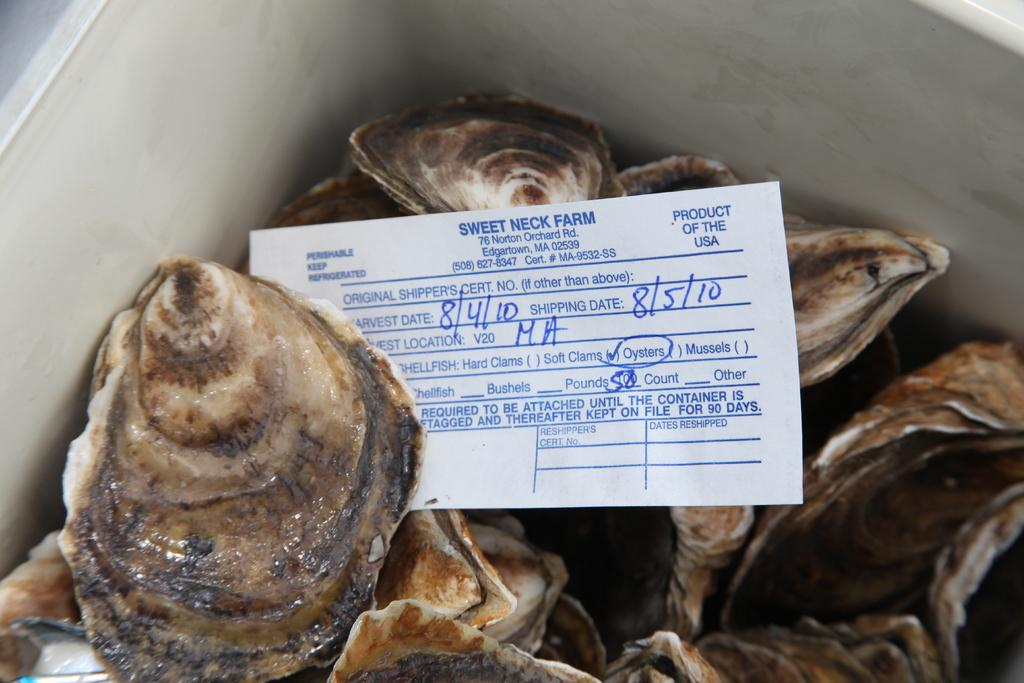What objects are present in the image? There are seashells in the image, which are kept in a box. How are the seashells stored? The seashells are kept in a box. What else can be seen in the image besides the seashells? There is a paper slip in the image. Where is the paper slip located in relation to the box of seashells? The paper slip is placed on the box of seashells. What type of notebook is being used by the seashells in the image? There is no notebook present in the image; the seashells are kept in a box. Can you describe the mind of the bee in the image? There are no bees present in the image, so it is not possible to describe the mind of a bee. 